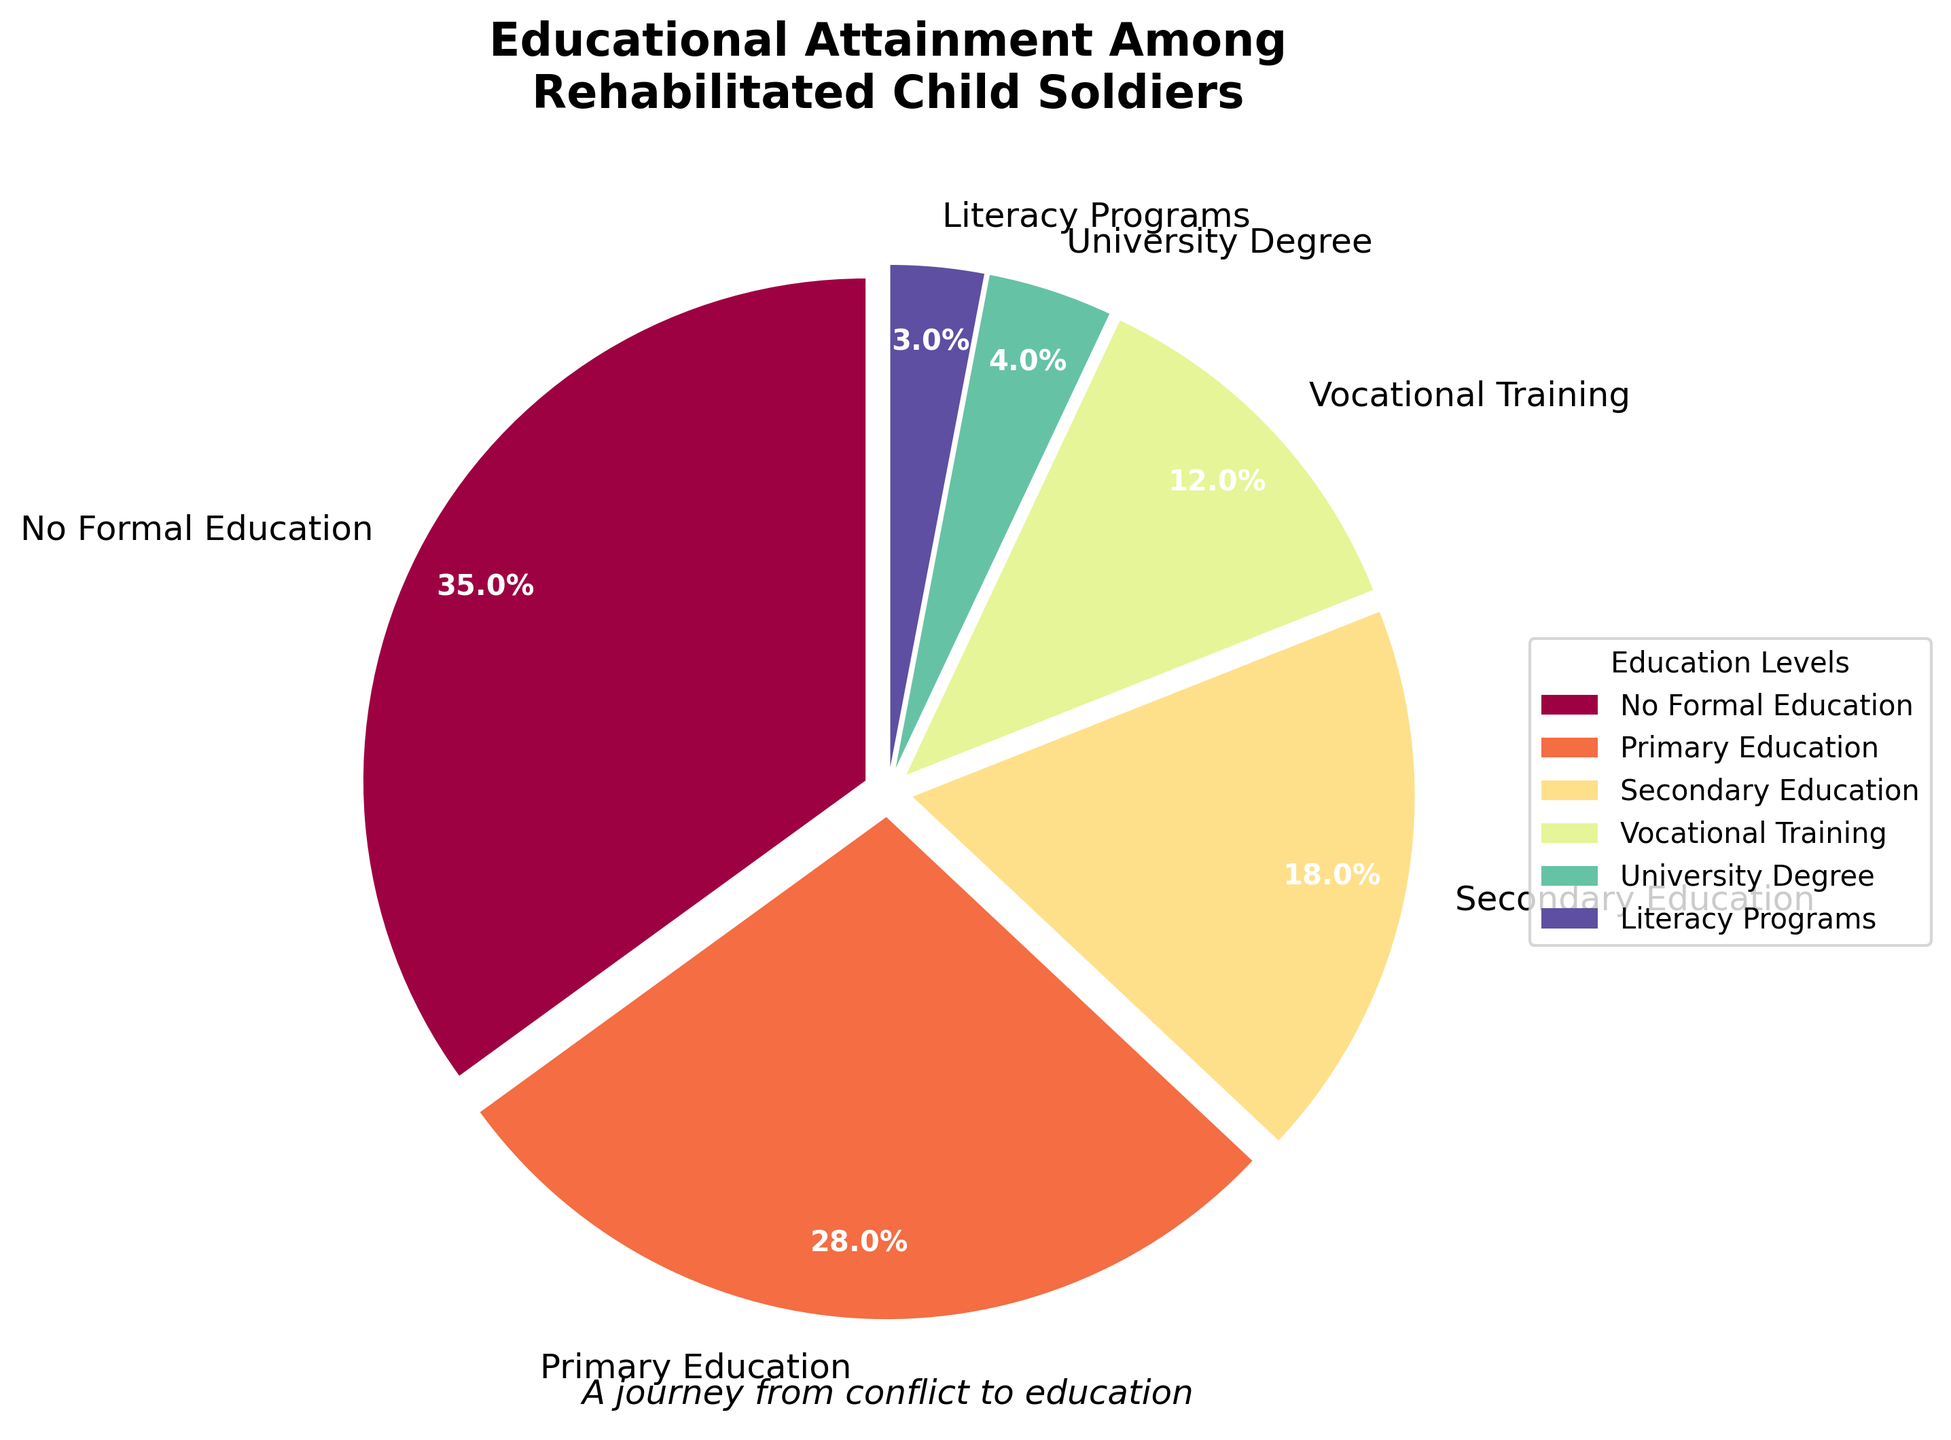what percentage of rehabilitated child soldiers received some form of primary or secondary education? To find the total percentage who received primary or secondary education, sum the percentages for both categories: Primary Education (28%) + Secondary Education (18%) = 46%.
Answer: 46% which educational level has the largest percentage, and what is it? Observe the sizes of the pie chart segments to identify the largest segment: The largest segment represents “No Formal Education” with a percentage of 35%.
Answer: No Formal Education, 35% how does the percentage of rehabilitated child soldiers with vocational training compare to those with university degrees? Compare the percentages of the pie chart segments for "Vocational Training" and "University Degree." “Vocational Training” has 12%, while “University Degree” has 4%. Since 12% is greater than 4%, vocational training is more common.
Answer: Vocational Training is greater (12% vs. 4%) which education levels have a percentage less than 5%? Identify the pie chart segments with percentages less than 5%: “University Degree” (4%) and “Literacy Programs” (3%) fall below this threshold.
Answer: University Degree and Literacy Programs what is the combined percentage of rehabilitated child soldiers who attended vocational training and literacy programs? Sum the percentages for “Vocational Training” (12%) and “Literacy Programs” (3%): 12% + 3% = 15%.
Answer: 15% what is the difference between the percentage of rehabilitated child soldiers with secondary education and those without any formal education? Subtract the percentage of “Secondary Education” (18%) from the percentage of “No Formal Education” (35%): 35% - 18% = 17%.
Answer: 17% which color represents the category with the lowest percentage in the pie chart? The “Literacy Programs” category has the lowest percentage (3%). To find the corresponding color, look for the smallest segment; visually, the color of this segment represents the lowest percentage.
Answer: The color representing the smallest segment (specific color identified visually) if 1000 rehabilitated child soldiers are surveyed, how many have some form of secondary education? Calculate the number of soldiers with secondary education: Percentage for Secondary Education is 18%. Thus, 1000 * 0.18 = 180 soldiers.
Answer: 180 of the categories primary education, vocational training, and university degree, which has the highest percentage, and what is the specific percentage? Compare the percentages of Primary Education (28%), Vocational Training (12%), and University Degree (4%). The highest percentage among these is Primary Education with 28%.
Answer: Primary Education (28%) which education level contributes the least to the educational attainment among rehabilitated child soldiers? Identify the pie chart segment with the smallest percentage: “Literacy Programs” has the smallest percentage at 3%.
Answer: Literacy Programs (3%) 